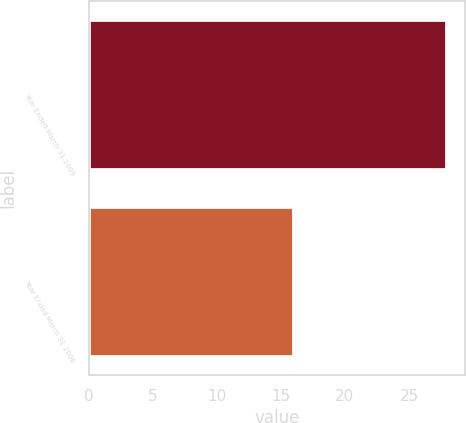<chart> <loc_0><loc_0><loc_500><loc_500><bar_chart><fcel>Year Ended March 31 2009<fcel>Year Ended March 31 2008<nl><fcel>28<fcel>16<nl></chart> 